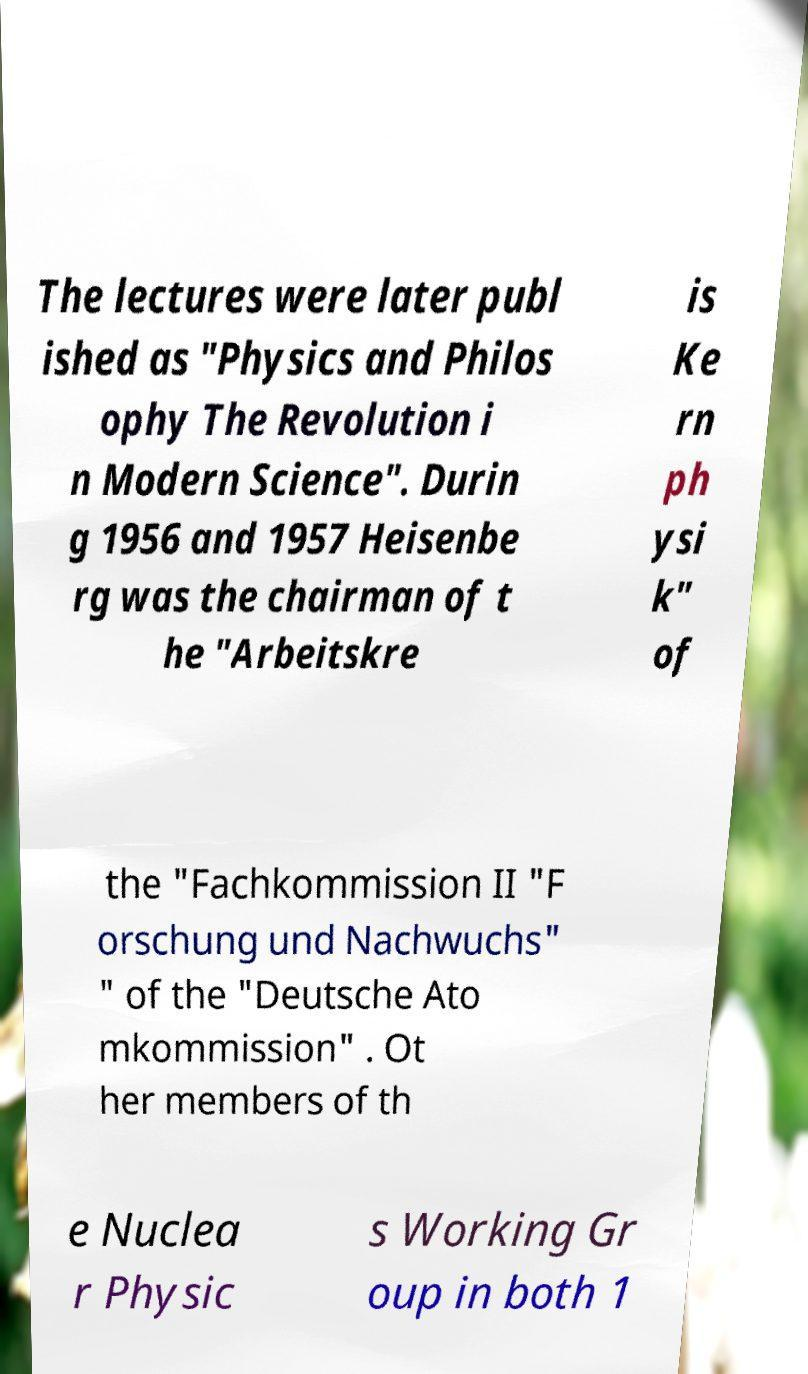Please read and relay the text visible in this image. What does it say? The lectures were later publ ished as "Physics and Philos ophy The Revolution i n Modern Science". Durin g 1956 and 1957 Heisenbe rg was the chairman of t he "Arbeitskre is Ke rn ph ysi k" of the "Fachkommission II "F orschung und Nachwuchs" " of the "Deutsche Ato mkommission" . Ot her members of th e Nuclea r Physic s Working Gr oup in both 1 